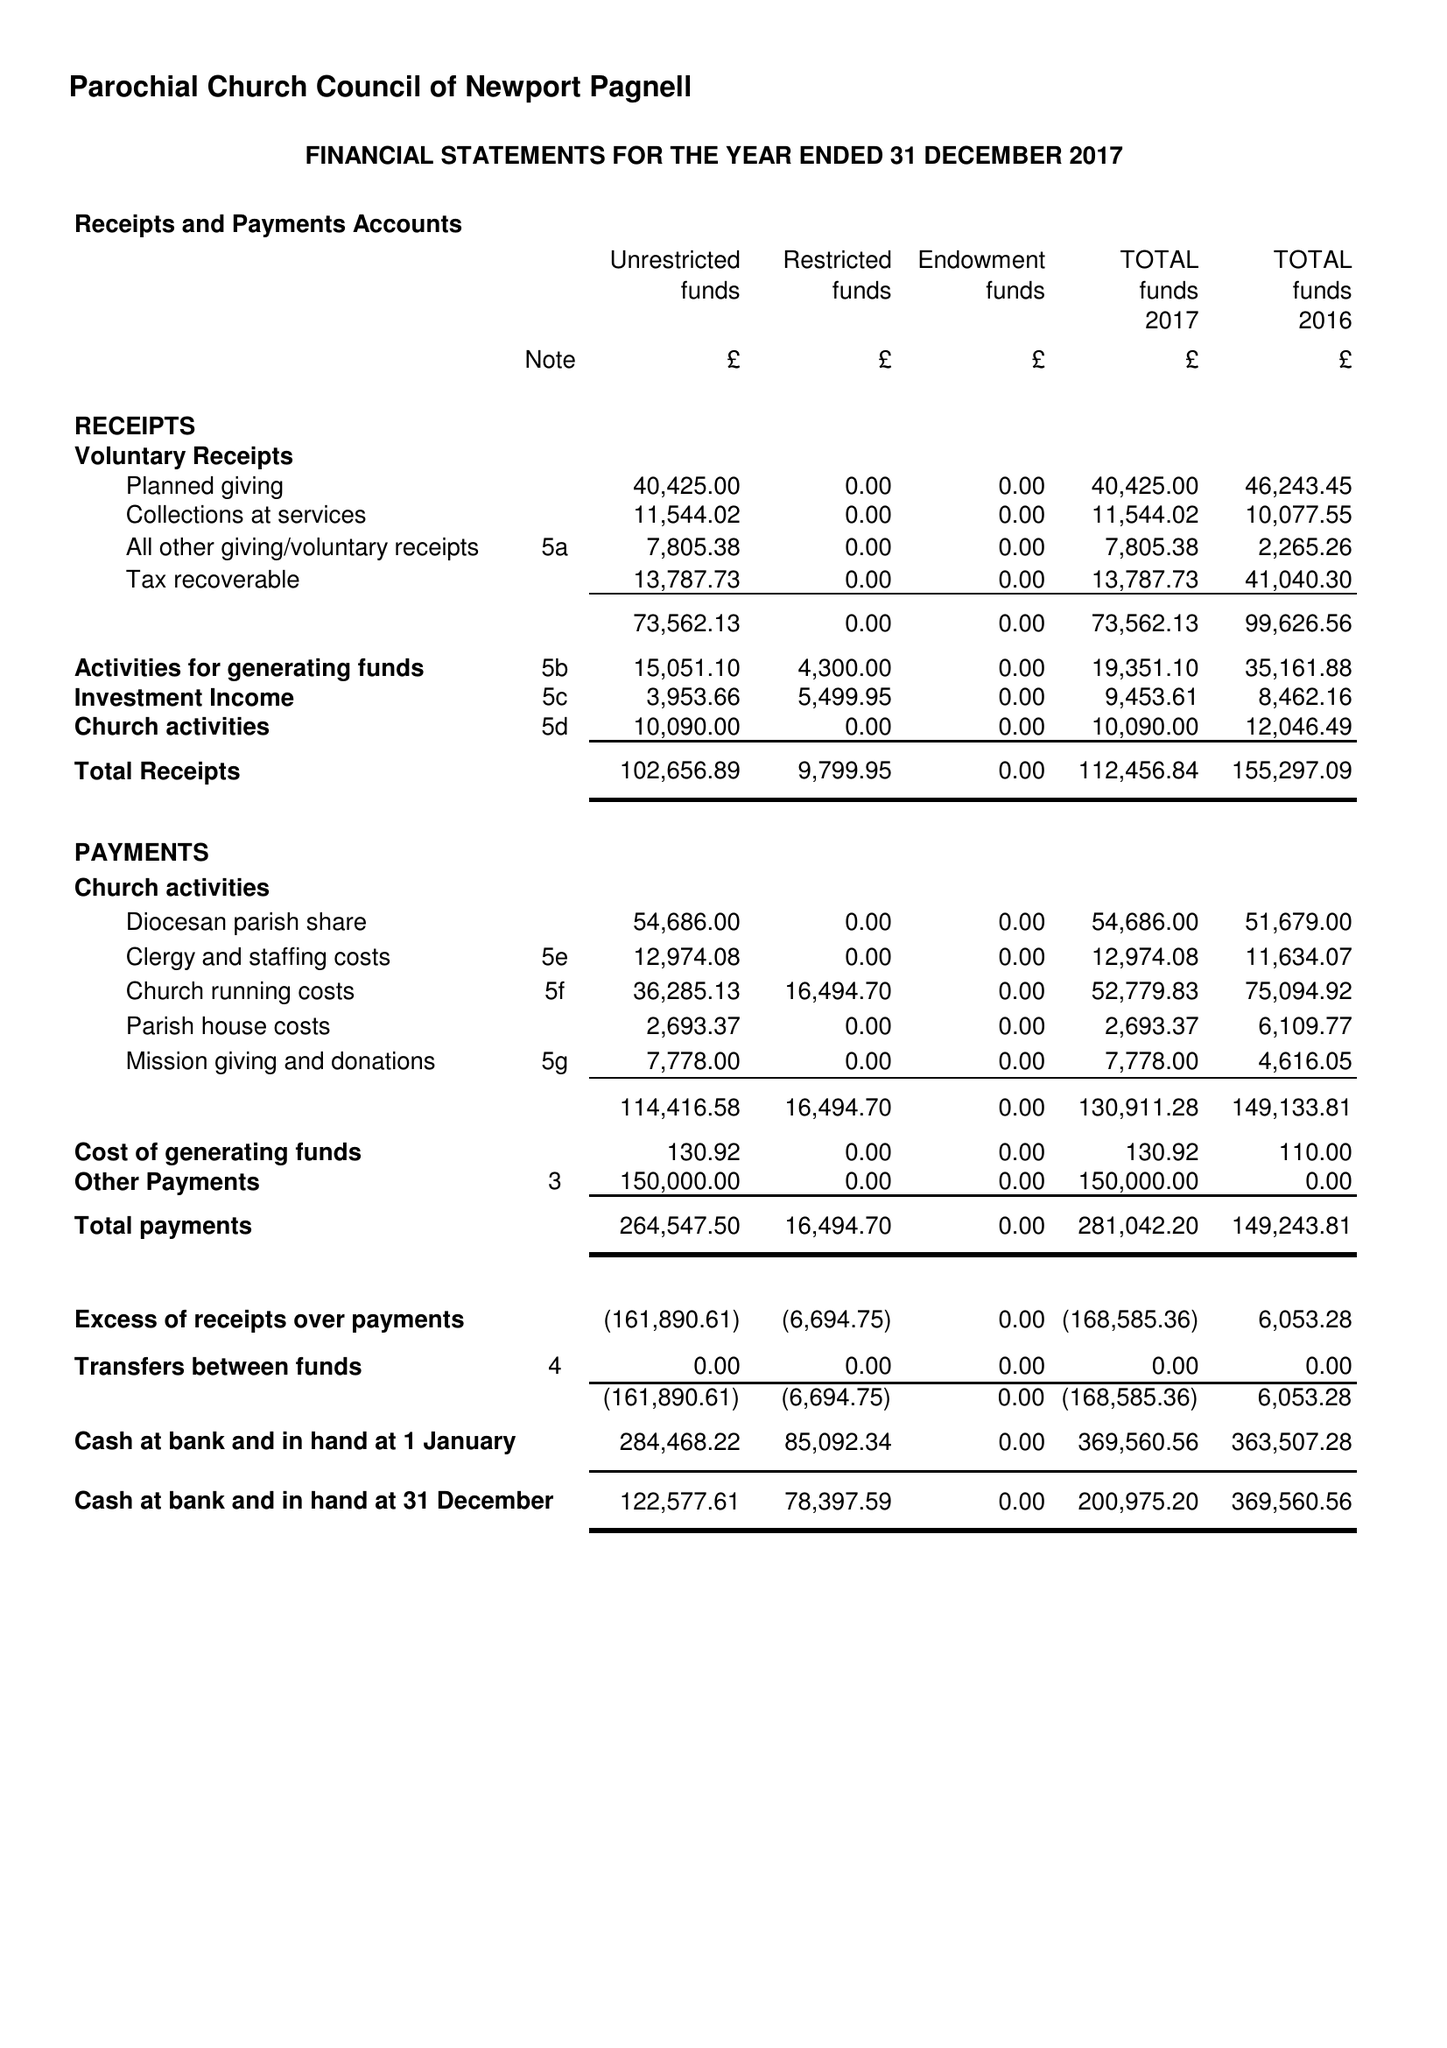What is the value for the income_annually_in_british_pounds?
Answer the question using a single word or phrase. 112457.00 